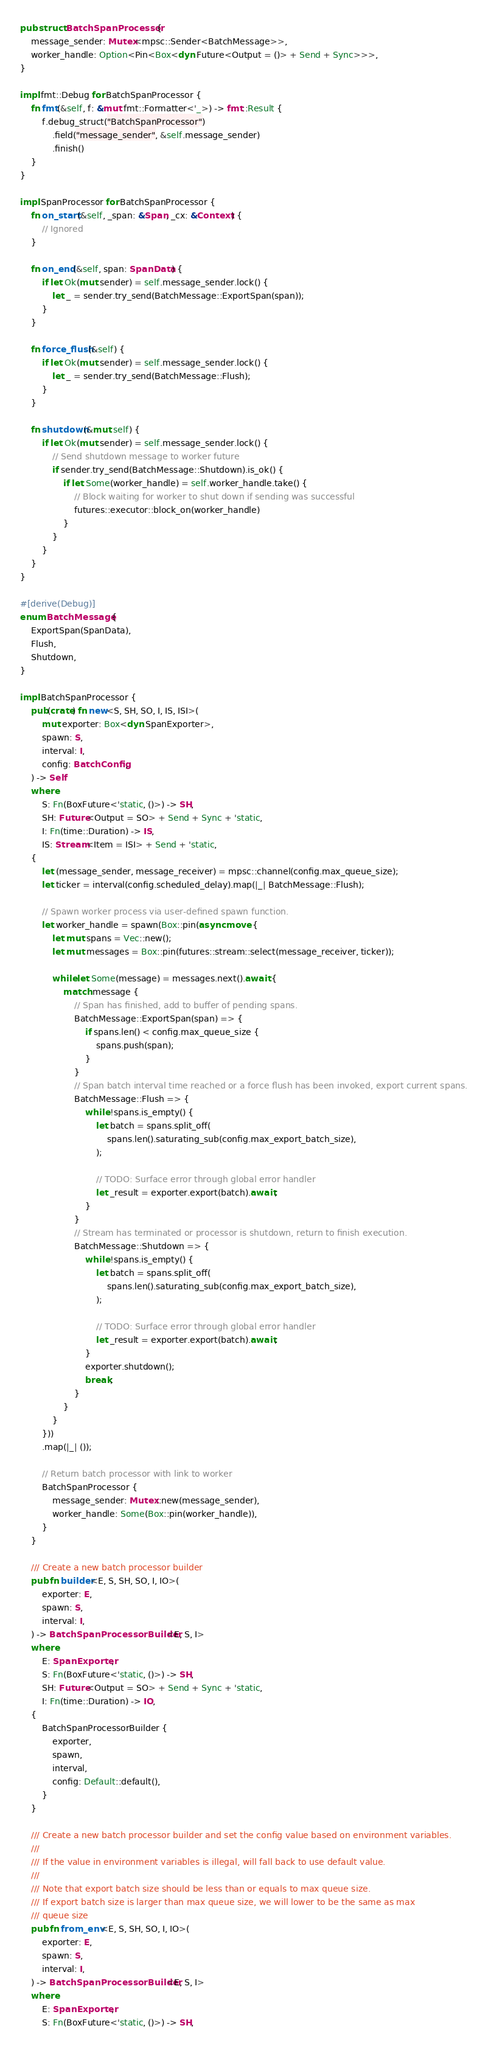Convert code to text. <code><loc_0><loc_0><loc_500><loc_500><_Rust_>pub struct BatchSpanProcessor {
    message_sender: Mutex<mpsc::Sender<BatchMessage>>,
    worker_handle: Option<Pin<Box<dyn Future<Output = ()> + Send + Sync>>>,
}

impl fmt::Debug for BatchSpanProcessor {
    fn fmt(&self, f: &mut fmt::Formatter<'_>) -> fmt::Result {
        f.debug_struct("BatchSpanProcessor")
            .field("message_sender", &self.message_sender)
            .finish()
    }
}

impl SpanProcessor for BatchSpanProcessor {
    fn on_start(&self, _span: &Span, _cx: &Context) {
        // Ignored
    }

    fn on_end(&self, span: SpanData) {
        if let Ok(mut sender) = self.message_sender.lock() {
            let _ = sender.try_send(BatchMessage::ExportSpan(span));
        }
    }

    fn force_flush(&self) {
        if let Ok(mut sender) = self.message_sender.lock() {
            let _ = sender.try_send(BatchMessage::Flush);
        }
    }

    fn shutdown(&mut self) {
        if let Ok(mut sender) = self.message_sender.lock() {
            // Send shutdown message to worker future
            if sender.try_send(BatchMessage::Shutdown).is_ok() {
                if let Some(worker_handle) = self.worker_handle.take() {
                    // Block waiting for worker to shut down if sending was successful
                    futures::executor::block_on(worker_handle)
                }
            }
        }
    }
}

#[derive(Debug)]
enum BatchMessage {
    ExportSpan(SpanData),
    Flush,
    Shutdown,
}

impl BatchSpanProcessor {
    pub(crate) fn new<S, SH, SO, I, IS, ISI>(
        mut exporter: Box<dyn SpanExporter>,
        spawn: S,
        interval: I,
        config: BatchConfig,
    ) -> Self
    where
        S: Fn(BoxFuture<'static, ()>) -> SH,
        SH: Future<Output = SO> + Send + Sync + 'static,
        I: Fn(time::Duration) -> IS,
        IS: Stream<Item = ISI> + Send + 'static,
    {
        let (message_sender, message_receiver) = mpsc::channel(config.max_queue_size);
        let ticker = interval(config.scheduled_delay).map(|_| BatchMessage::Flush);

        // Spawn worker process via user-defined spawn function.
        let worker_handle = spawn(Box::pin(async move {
            let mut spans = Vec::new();
            let mut messages = Box::pin(futures::stream::select(message_receiver, ticker));

            while let Some(message) = messages.next().await {
                match message {
                    // Span has finished, add to buffer of pending spans.
                    BatchMessage::ExportSpan(span) => {
                        if spans.len() < config.max_queue_size {
                            spans.push(span);
                        }
                    }
                    // Span batch interval time reached or a force flush has been invoked, export current spans.
                    BatchMessage::Flush => {
                        while !spans.is_empty() {
                            let batch = spans.split_off(
                                spans.len().saturating_sub(config.max_export_batch_size),
                            );

                            // TODO: Surface error through global error handler
                            let _result = exporter.export(batch).await;
                        }
                    }
                    // Stream has terminated or processor is shutdown, return to finish execution.
                    BatchMessage::Shutdown => {
                        while !spans.is_empty() {
                            let batch = spans.split_off(
                                spans.len().saturating_sub(config.max_export_batch_size),
                            );

                            // TODO: Surface error through global error handler
                            let _result = exporter.export(batch).await;
                        }
                        exporter.shutdown();
                        break;
                    }
                }
            }
        }))
        .map(|_| ());

        // Return batch processor with link to worker
        BatchSpanProcessor {
            message_sender: Mutex::new(message_sender),
            worker_handle: Some(Box::pin(worker_handle)),
        }
    }

    /// Create a new batch processor builder
    pub fn builder<E, S, SH, SO, I, IO>(
        exporter: E,
        spawn: S,
        interval: I,
    ) -> BatchSpanProcessorBuilder<E, S, I>
    where
        E: SpanExporter,
        S: Fn(BoxFuture<'static, ()>) -> SH,
        SH: Future<Output = SO> + Send + Sync + 'static,
        I: Fn(time::Duration) -> IO,
    {
        BatchSpanProcessorBuilder {
            exporter,
            spawn,
            interval,
            config: Default::default(),
        }
    }

    /// Create a new batch processor builder and set the config value based on environment variables.
    ///
    /// If the value in environment variables is illegal, will fall back to use default value.
    ///
    /// Note that export batch size should be less than or equals to max queue size.
    /// If export batch size is larger than max queue size, we will lower to be the same as max
    /// queue size
    pub fn from_env<E, S, SH, SO, I, IO>(
        exporter: E,
        spawn: S,
        interval: I,
    ) -> BatchSpanProcessorBuilder<E, S, I>
    where
        E: SpanExporter,
        S: Fn(BoxFuture<'static, ()>) -> SH,</code> 